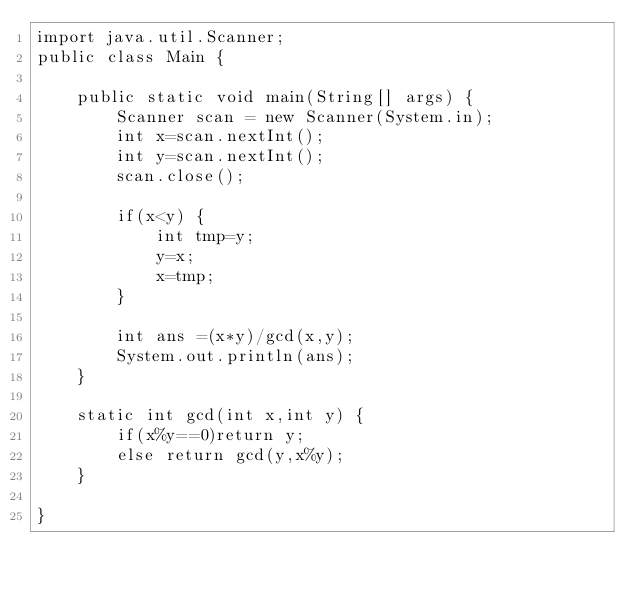<code> <loc_0><loc_0><loc_500><loc_500><_Java_>import java.util.Scanner;
public class Main {

	public static void main(String[] args) {
		Scanner scan = new Scanner(System.in);
		int x=scan.nextInt();
		int y=scan.nextInt();
		scan.close();

		if(x<y) {
			int tmp=y;
			y=x;
			x=tmp;
		}

		int ans =(x*y)/gcd(x,y);
		System.out.println(ans);
	}

	static int gcd(int x,int y) {
		if(x%y==0)return y;
		else return gcd(y,x%y);
	}

}</code> 